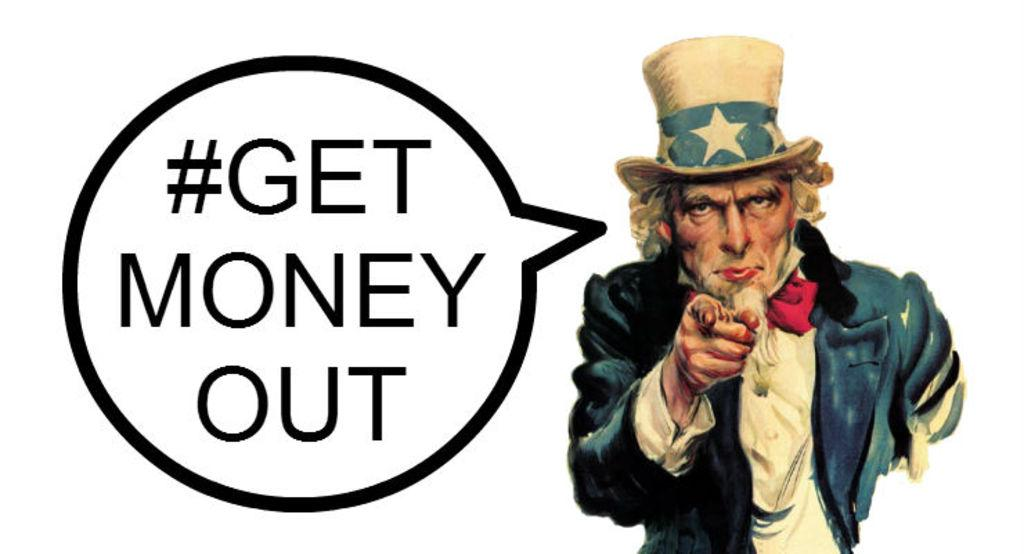What is located on the right side of the image? There is a person on the right side of the image. What can be seen on the left side of the image? There is text on the left side of the image. How many worms are crawling on the person's hat in the image? There is no hat or worms present in the image. What time of day is depicted in the image? The provided facts do not mention the time of day, so it cannot be determined from the image. 